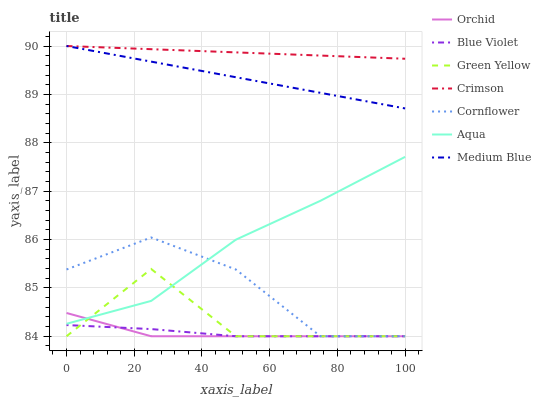Does Orchid have the minimum area under the curve?
Answer yes or no. Yes. Does Crimson have the maximum area under the curve?
Answer yes or no. Yes. Does Medium Blue have the minimum area under the curve?
Answer yes or no. No. Does Medium Blue have the maximum area under the curve?
Answer yes or no. No. Is Crimson the smoothest?
Answer yes or no. Yes. Is Green Yellow the roughest?
Answer yes or no. Yes. Is Medium Blue the smoothest?
Answer yes or no. No. Is Medium Blue the roughest?
Answer yes or no. No. Does Cornflower have the lowest value?
Answer yes or no. Yes. Does Medium Blue have the lowest value?
Answer yes or no. No. Does Crimson have the highest value?
Answer yes or no. Yes. Does Aqua have the highest value?
Answer yes or no. No. Is Green Yellow less than Medium Blue?
Answer yes or no. Yes. Is Crimson greater than Aqua?
Answer yes or no. Yes. Does Cornflower intersect Blue Violet?
Answer yes or no. Yes. Is Cornflower less than Blue Violet?
Answer yes or no. No. Is Cornflower greater than Blue Violet?
Answer yes or no. No. Does Green Yellow intersect Medium Blue?
Answer yes or no. No. 